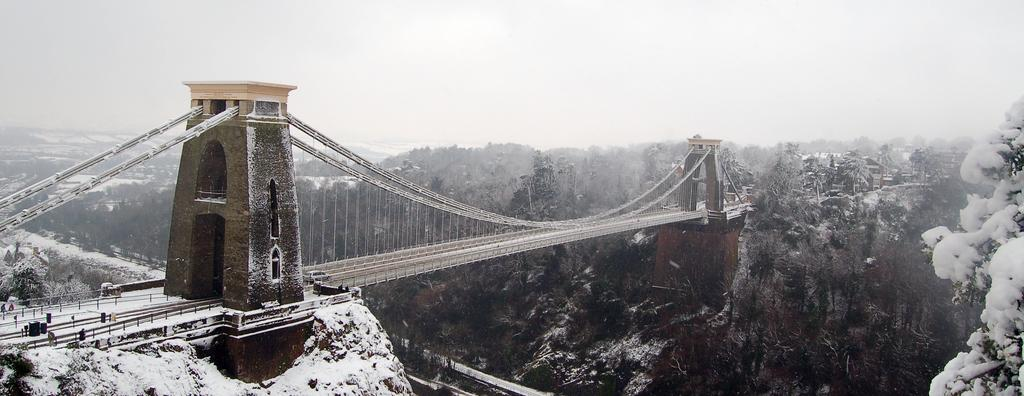What type of structure can be seen in the image? There is a bridge in the image. What type of vegetation is present in the image? There are trees in the image. What is the weather like in the image? There is snow in the image, indicating a cold or wintery environment. What type of buildings can be seen in the image? There are houses in the image. What type of natural landform is visible in the image? There are mountains in the image. What else can be seen in the image besides the mentioned objects? There are other objects in the image, but their specific details are not provided. What is visible in the background of the image? The sky is visible in the background of the image. What type of wood is used to build the event in the image? There is no event present in the image, and therefore no wood can be associated with it. 